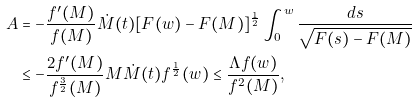<formula> <loc_0><loc_0><loc_500><loc_500>A & = - \frac { f ^ { \prime } ( M ) } { f ( M ) } \dot { M } ( t ) [ F ( w ) - F ( M ) ] ^ { \frac { 1 } { 2 } } \int _ { 0 } ^ { w } \frac { d s } { \sqrt { F ( s ) - F ( M ) } } \\ & \leq - \frac { 2 f ^ { \prime } ( M ) } { f ^ { \frac { 3 } { 2 } } ( M ) } M \dot { M } ( t ) f ^ { \frac { 1 } { 2 } } ( w ) \leq \frac { \Lambda f ( w ) } { f ^ { 2 } ( M ) } ,</formula> 